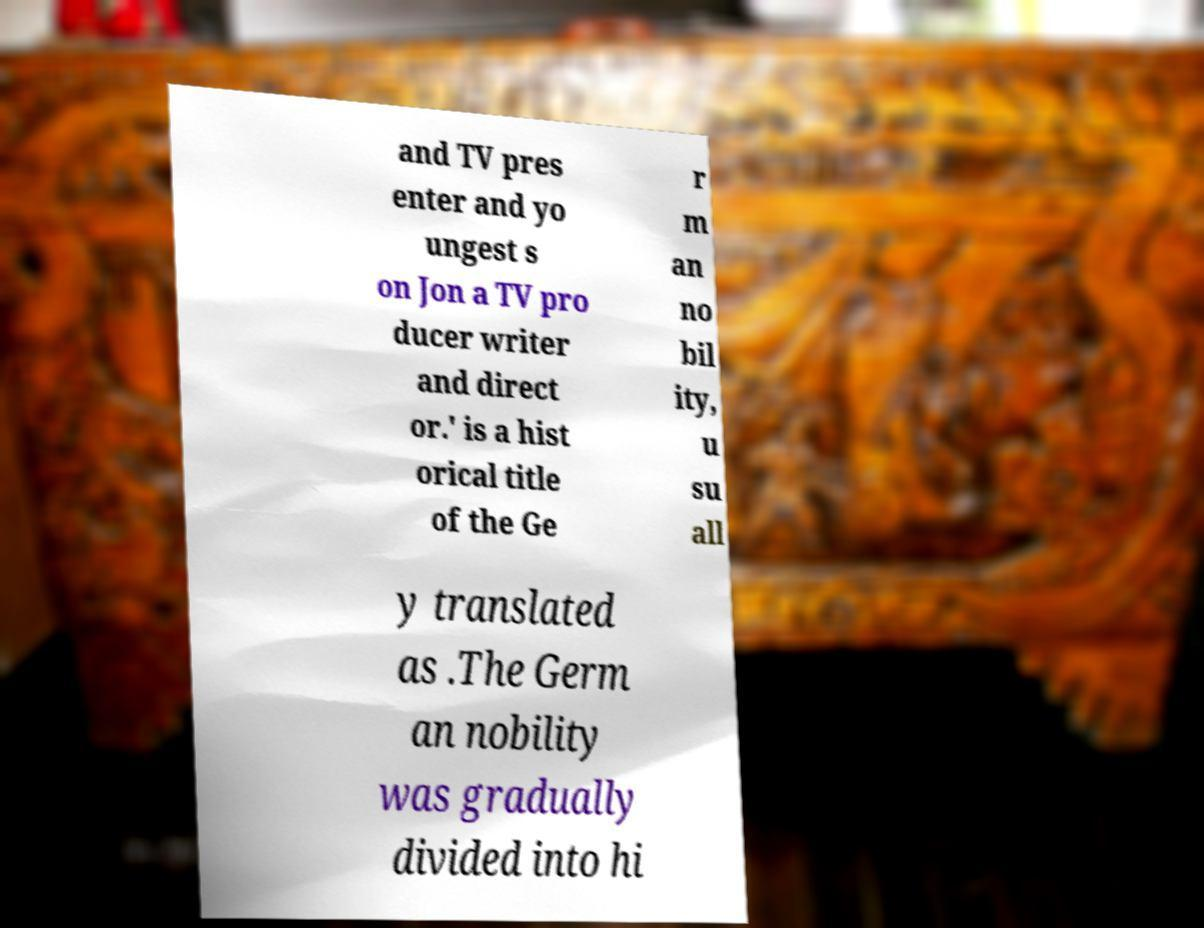For documentation purposes, I need the text within this image transcribed. Could you provide that? and TV pres enter and yo ungest s on Jon a TV pro ducer writer and direct or.' is a hist orical title of the Ge r m an no bil ity, u su all y translated as .The Germ an nobility was gradually divided into hi 